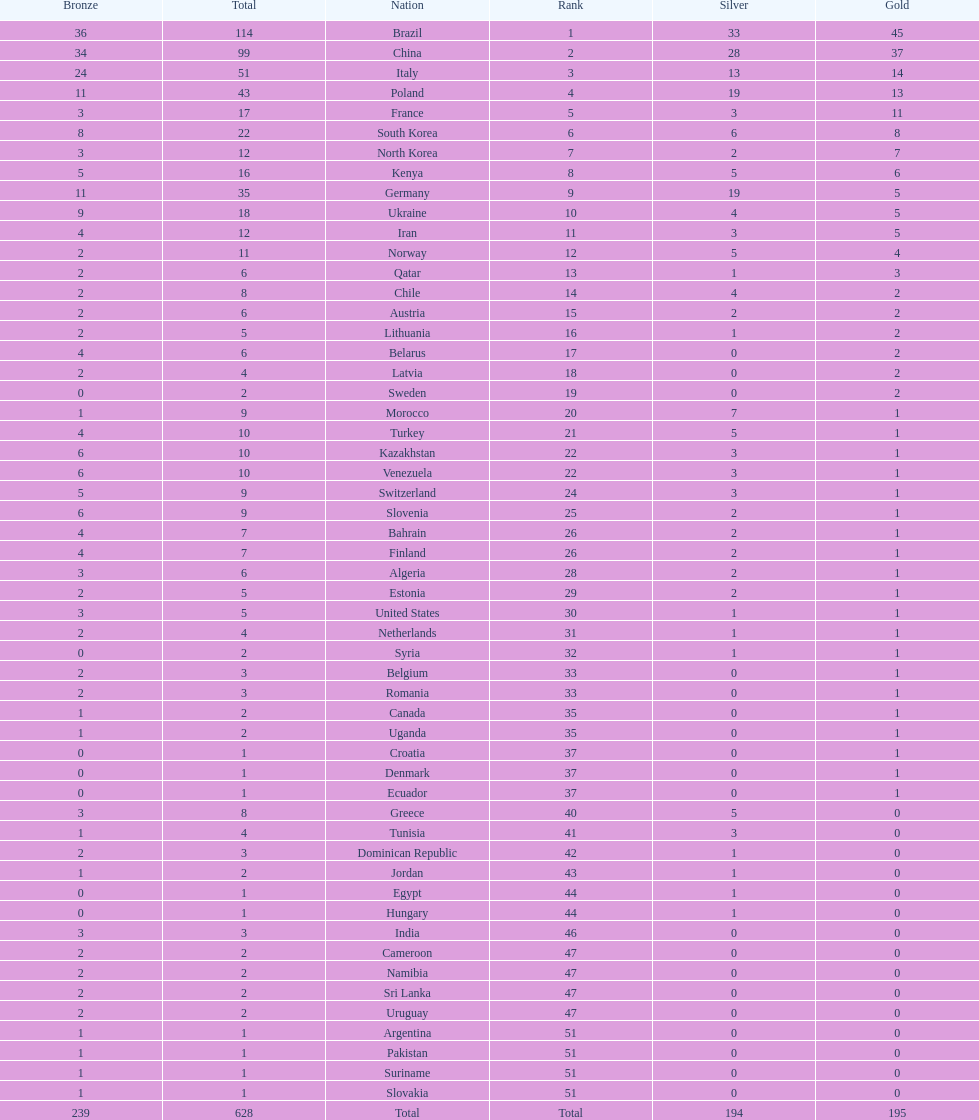Which type of medal does belarus not have? Silver. 